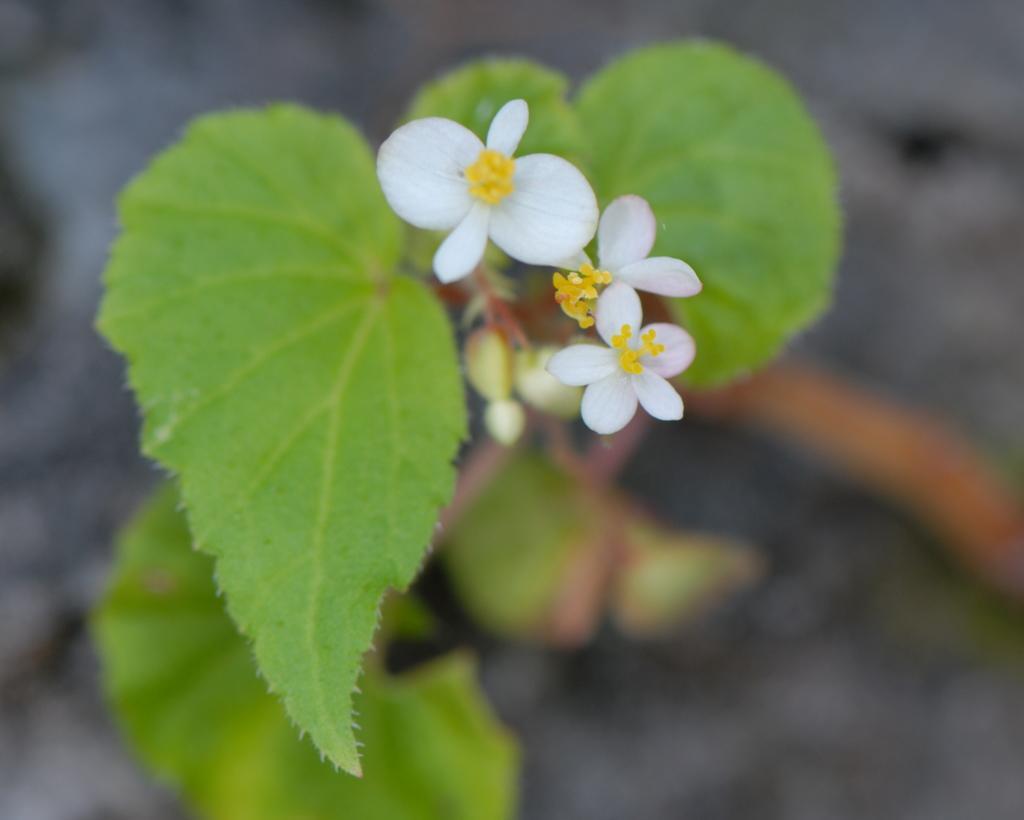Please provide a concise description of this image. In the foreground of the picture there are flowers and leaves. The background is blurred. 